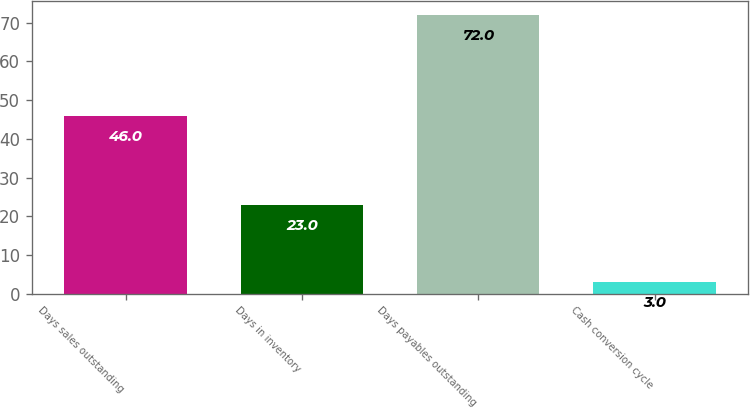Convert chart to OTSL. <chart><loc_0><loc_0><loc_500><loc_500><bar_chart><fcel>Days sales outstanding<fcel>Days in inventory<fcel>Days payables outstanding<fcel>Cash conversion cycle<nl><fcel>46<fcel>23<fcel>72<fcel>3<nl></chart> 